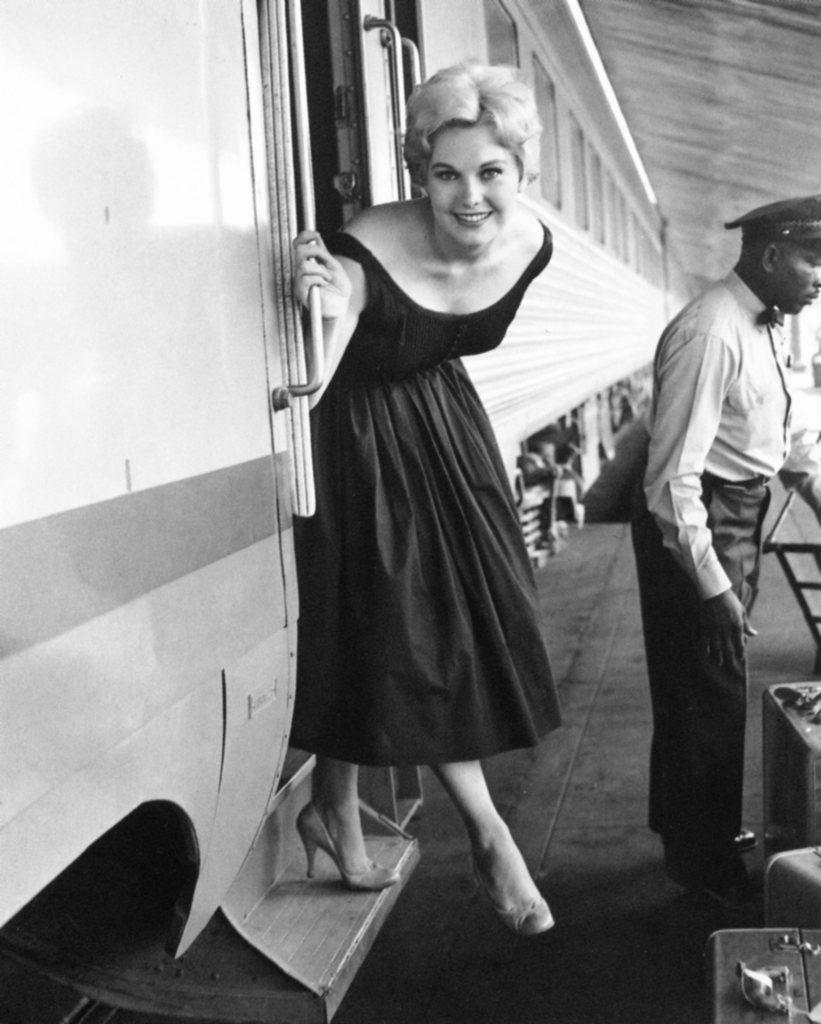Please provide a concise description of this image. This is a black and white image. In the center of the image we can see women on the train. On the right side of the image we can see persons standing. 